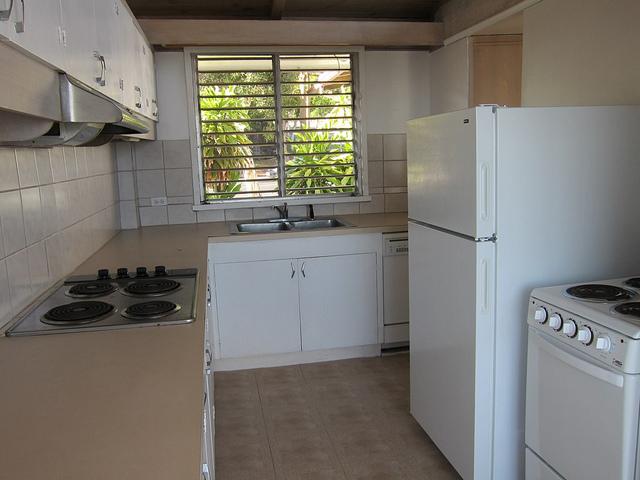Is this kitchen clean or dirty?
Quick response, please. Clean. Is the refrigerator white?
Answer briefly. Yes. Is there any evidence of people living here?
Be succinct. No. What room of the house is this?
Concise answer only. Kitchen. 